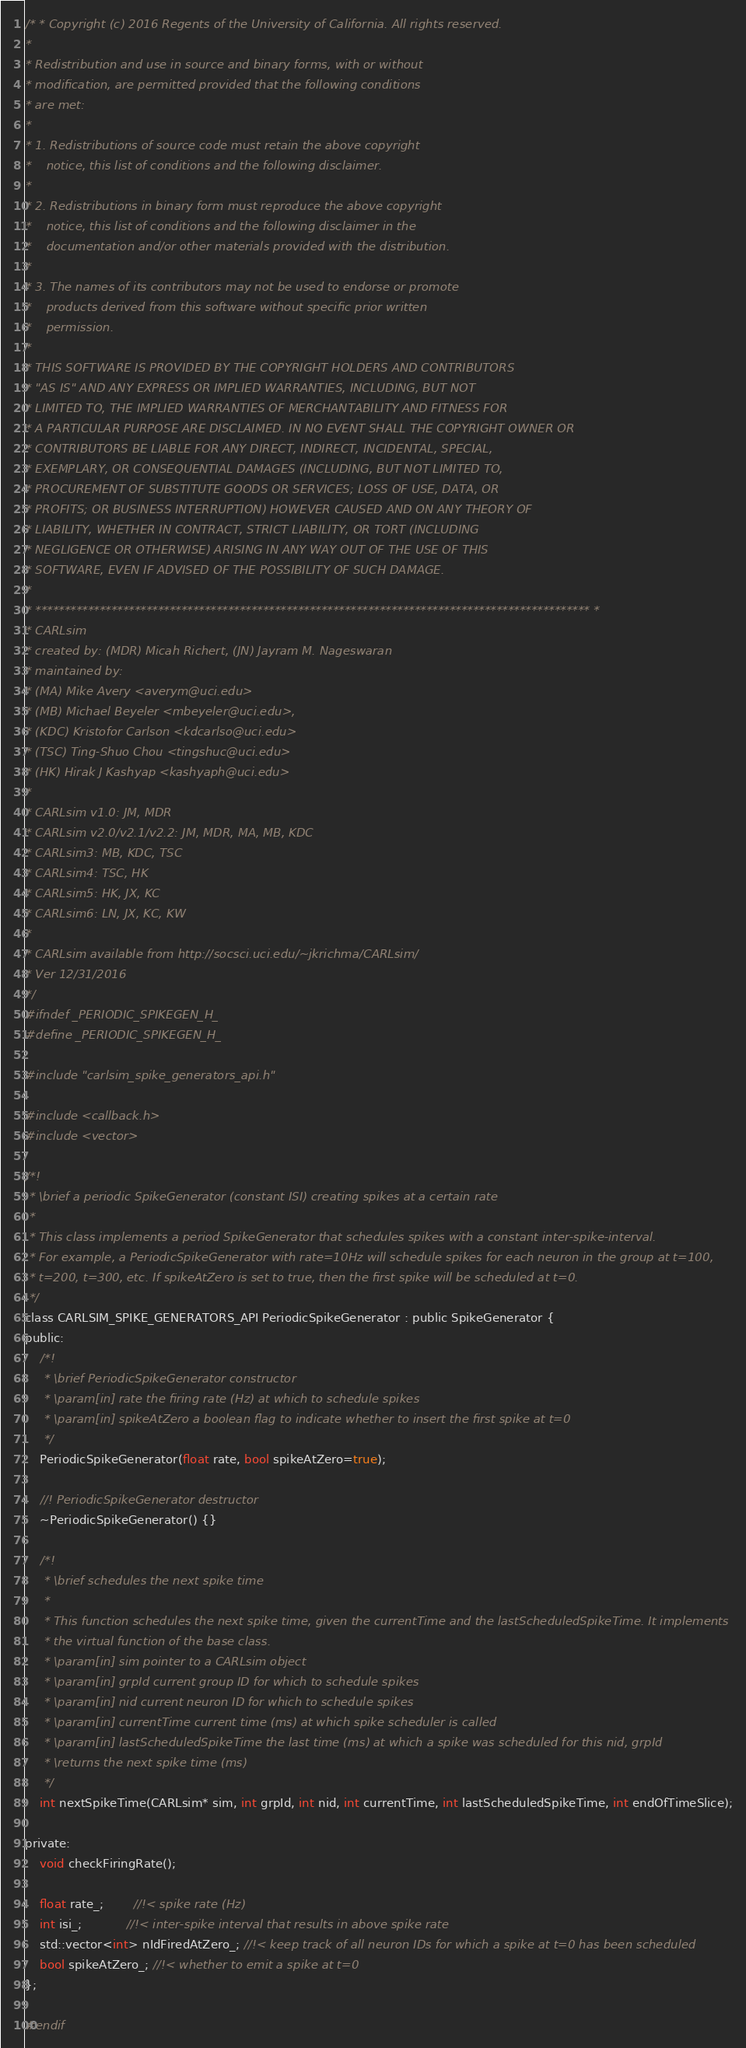<code> <loc_0><loc_0><loc_500><loc_500><_C_>/* * Copyright (c) 2016 Regents of the University of California. All rights reserved.
*
* Redistribution and use in source and binary forms, with or without
* modification, are permitted provided that the following conditions
* are met:
*
* 1. Redistributions of source code must retain the above copyright
*    notice, this list of conditions and the following disclaimer.
*
* 2. Redistributions in binary form must reproduce the above copyright
*    notice, this list of conditions and the following disclaimer in the
*    documentation and/or other materials provided with the distribution.
*
* 3. The names of its contributors may not be used to endorse or promote
*    products derived from this software without specific prior written
*    permission.
*
* THIS SOFTWARE IS PROVIDED BY THE COPYRIGHT HOLDERS AND CONTRIBUTORS
* "AS IS" AND ANY EXPRESS OR IMPLIED WARRANTIES, INCLUDING, BUT NOT
* LIMITED TO, THE IMPLIED WARRANTIES OF MERCHANTABILITY AND FITNESS FOR
* A PARTICULAR PURPOSE ARE DISCLAIMED. IN NO EVENT SHALL THE COPYRIGHT OWNER OR
* CONTRIBUTORS BE LIABLE FOR ANY DIRECT, INDIRECT, INCIDENTAL, SPECIAL,
* EXEMPLARY, OR CONSEQUENTIAL DAMAGES (INCLUDING, BUT NOT LIMITED TO,
* PROCUREMENT OF SUBSTITUTE GOODS OR SERVICES; LOSS OF USE, DATA, OR
* PROFITS; OR BUSINESS INTERRUPTION) HOWEVER CAUSED AND ON ANY THEORY OF
* LIABILITY, WHETHER IN CONTRACT, STRICT LIABILITY, OR TORT (INCLUDING
* NEGLIGENCE OR OTHERWISE) ARISING IN ANY WAY OUT OF THE USE OF THIS
* SOFTWARE, EVEN IF ADVISED OF THE POSSIBILITY OF SUCH DAMAGE.
*
* *********************************************************************************************** *
* CARLsim
* created by: (MDR) Micah Richert, (JN) Jayram M. Nageswaran
* maintained by:
* (MA) Mike Avery <averym@uci.edu>
* (MB) Michael Beyeler <mbeyeler@uci.edu>,
* (KDC) Kristofor Carlson <kdcarlso@uci.edu>
* (TSC) Ting-Shuo Chou <tingshuc@uci.edu>
* (HK) Hirak J Kashyap <kashyaph@uci.edu>
*
* CARLsim v1.0: JM, MDR
* CARLsim v2.0/v2.1/v2.2: JM, MDR, MA, MB, KDC
* CARLsim3: MB, KDC, TSC
* CARLsim4: TSC, HK
* CARLsim5: HK, JX, KC
* CARLsim6: LN, JX, KC, KW
*
* CARLsim available from http://socsci.uci.edu/~jkrichma/CARLsim/
* Ver 12/31/2016
*/
#ifndef _PERIODIC_SPIKEGEN_H_
#define _PERIODIC_SPIKEGEN_H_

#include "carlsim_spike_generators_api.h"

#include <callback.h>
#include <vector>

/*!
 * \brief a periodic SpikeGenerator (constant ISI) creating spikes at a certain rate
 *
 * This class implements a period SpikeGenerator that schedules spikes with a constant inter-spike-interval.
 * For example, a PeriodicSpikeGenerator with rate=10Hz will schedule spikes for each neuron in the group at t=100,
 * t=200, t=300, etc. If spikeAtZero is set to true, then the first spike will be scheduled at t=0.
 */
class CARLSIM_SPIKE_GENERATORS_API PeriodicSpikeGenerator : public SpikeGenerator {
public:
	/*!
	 * \brief PeriodicSpikeGenerator constructor
	 * \param[in] rate the firing rate (Hz) at which to schedule spikes
	 * \param[in] spikeAtZero a boolean flag to indicate whether to insert the first spike at t=0
	 */
	PeriodicSpikeGenerator(float rate, bool spikeAtZero=true);

	//! PeriodicSpikeGenerator destructor
	~PeriodicSpikeGenerator() {}

	/*!
	 * \brief schedules the next spike time
	 *
	 * This function schedules the next spike time, given the currentTime and the lastScheduledSpikeTime. It implements
	 * the virtual function of the base class.
	 * \param[in] sim pointer to a CARLsim object
	 * \param[in] grpId current group ID for which to schedule spikes
	 * \param[in] nid current neuron ID for which to schedule spikes
	 * \param[in] currentTime current time (ms) at which spike scheduler is called
	 * \param[in] lastScheduledSpikeTime the last time (ms) at which a spike was scheduled for this nid, grpId
	 * \returns the next spike time (ms)
	 */
	int nextSpikeTime(CARLsim* sim, int grpId, int nid, int currentTime, int lastScheduledSpikeTime, int endOfTimeSlice);

private:
	void checkFiringRate();
	
	float rate_;		//!< spike rate (Hz)
	int isi_;			//!< inter-spike interval that results in above spike rate
	std::vector<int> nIdFiredAtZero_; //!< keep track of all neuron IDs for which a spike at t=0 has been scheduled
	bool spikeAtZero_; //!< whether to emit a spike at t=0
};

#endif</code> 